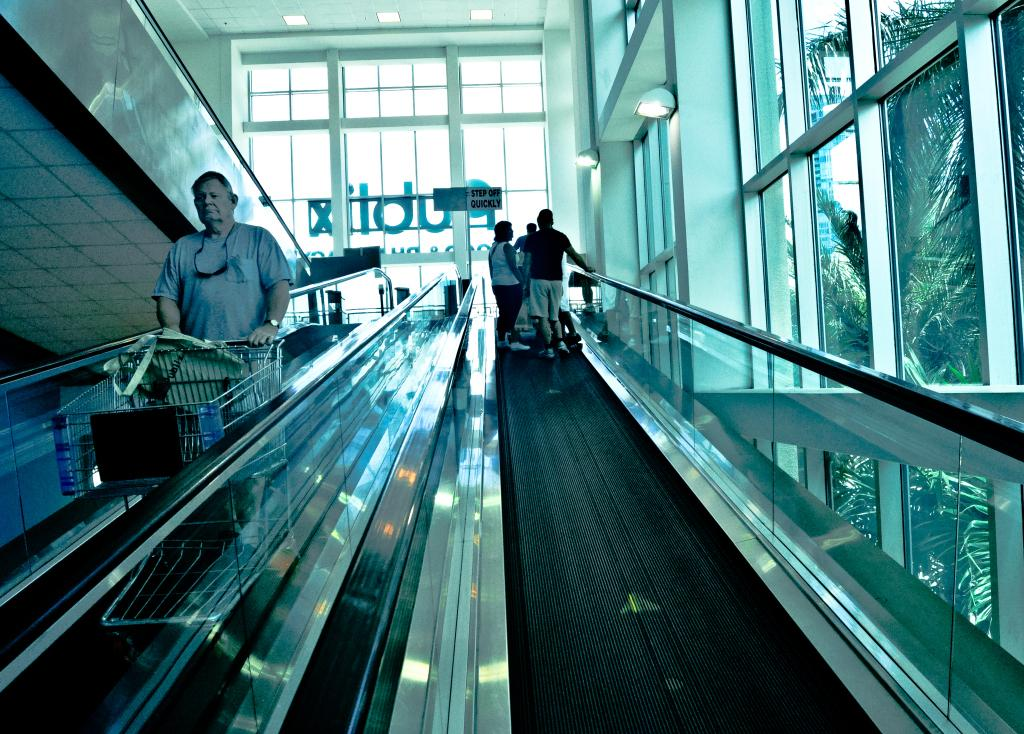<image>
Describe the image concisely. An escalator with a sign at the end that tells people to step off quickly 